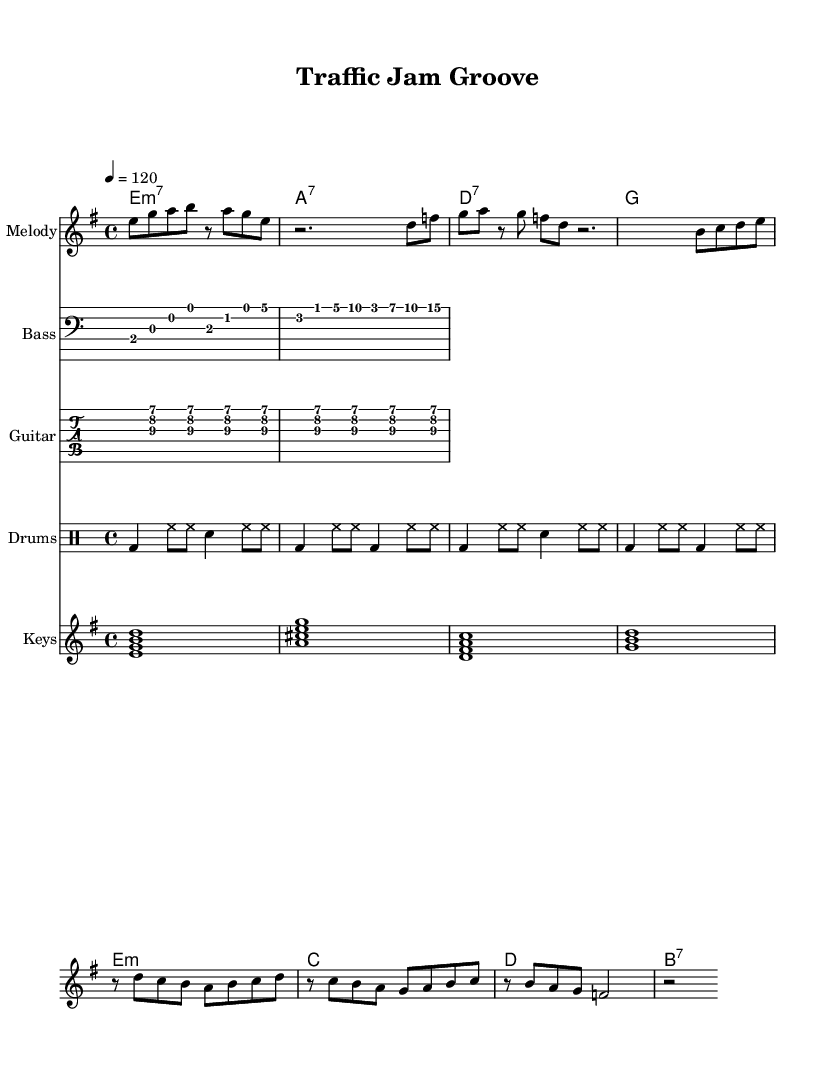what is the key signature of this music? The key signature is indicated at the beginning of the score, which shows two sharps. This corresponds to the key of E minor.
Answer: E minor what is the time signature of this music? The time signature is found at the beginning of the score and is indicated as 4/4. This means there are four beats per measure, and the quarter note gets one beat.
Answer: 4/4 what is the tempo of this music? The tempo is marked at the beginning of the score with the indication '4 = 120'. This means there are 120 beats per minute.
Answer: 120 how many measures are in the melody? To find the number of measures, we can count from the beginning of the melody section until it ends. There are a total of four measures in the verse and four more in the chorus, making eight measures.
Answer: 8 what type of harmony is used in the keyboard part? The harmony is indicated by the chord symbols below the staff, which in this case are played as extended chords. These include E minor 7 and A7, indicating a funk style.
Answer: Extended chords what instrument plays the bass line? The bass line is indicated in the score under the staff labeled "Bass," which is specifically for bass instruments.
Answer: Bass what is the main theme of the chorus melody? Analyzing the chorus melody, it rises and falls in a repetitive pattern between the notes B, C, D, and E, emphasizing resilience, which is key in funk music about perseverance.
Answer: Resilience 